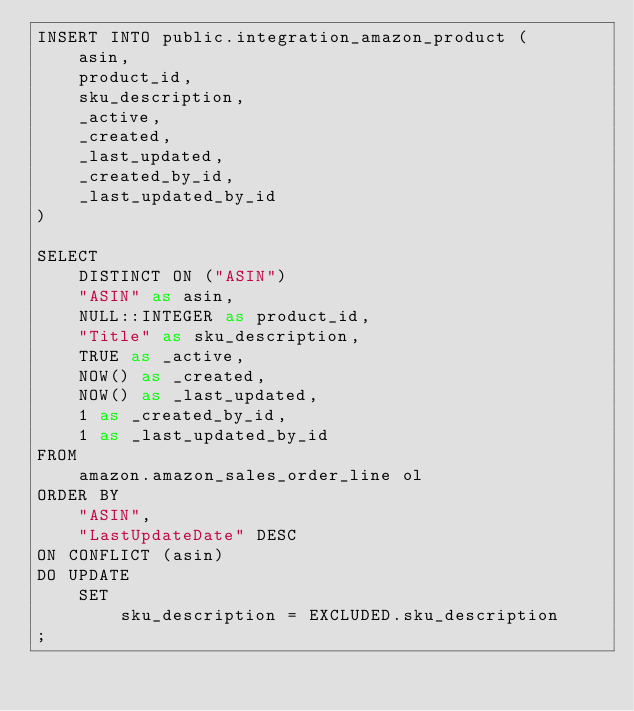Convert code to text. <code><loc_0><loc_0><loc_500><loc_500><_SQL_>INSERT INTO public.integration_amazon_product (
    asin,
    product_id,
    sku_description,
    _active,
    _created,
    _last_updated,
    _created_by_id,
    _last_updated_by_id
)

SELECT 
    DISTINCT ON ("ASIN")
    "ASIN" as asin,
    NULL::INTEGER as product_id,
    "Title" as sku_description,
    TRUE as _active,
    NOW() as _created,
    NOW() as _last_updated,
    1 as _created_by_id,
    1 as _last_updated_by_id
FROM
    amazon.amazon_sales_order_line ol
ORDER BY
    "ASIN",
    "LastUpdateDate" DESC
ON CONFLICT (asin)
DO UPDATE
    SET
        sku_description = EXCLUDED.sku_description
;
</code> 